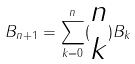Convert formula to latex. <formula><loc_0><loc_0><loc_500><loc_500>B _ { n + 1 } = \sum _ { k = 0 } ^ { n } ( \begin{matrix} n \\ k \end{matrix} ) B _ { k }</formula> 